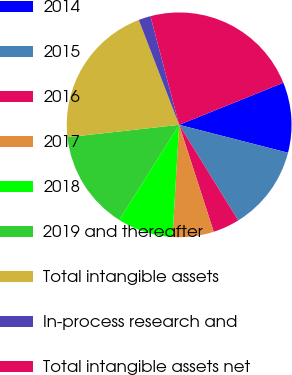<chart> <loc_0><loc_0><loc_500><loc_500><pie_chart><fcel>2014<fcel>2015<fcel>2016<fcel>2017<fcel>2018<fcel>2019 and thereafter<fcel>Total intangible assets<fcel>In-process research and<fcel>Total intangible assets net<nl><fcel>10.1%<fcel>12.2%<fcel>3.83%<fcel>5.92%<fcel>8.01%<fcel>14.29%<fcel>20.91%<fcel>1.74%<fcel>23.0%<nl></chart> 